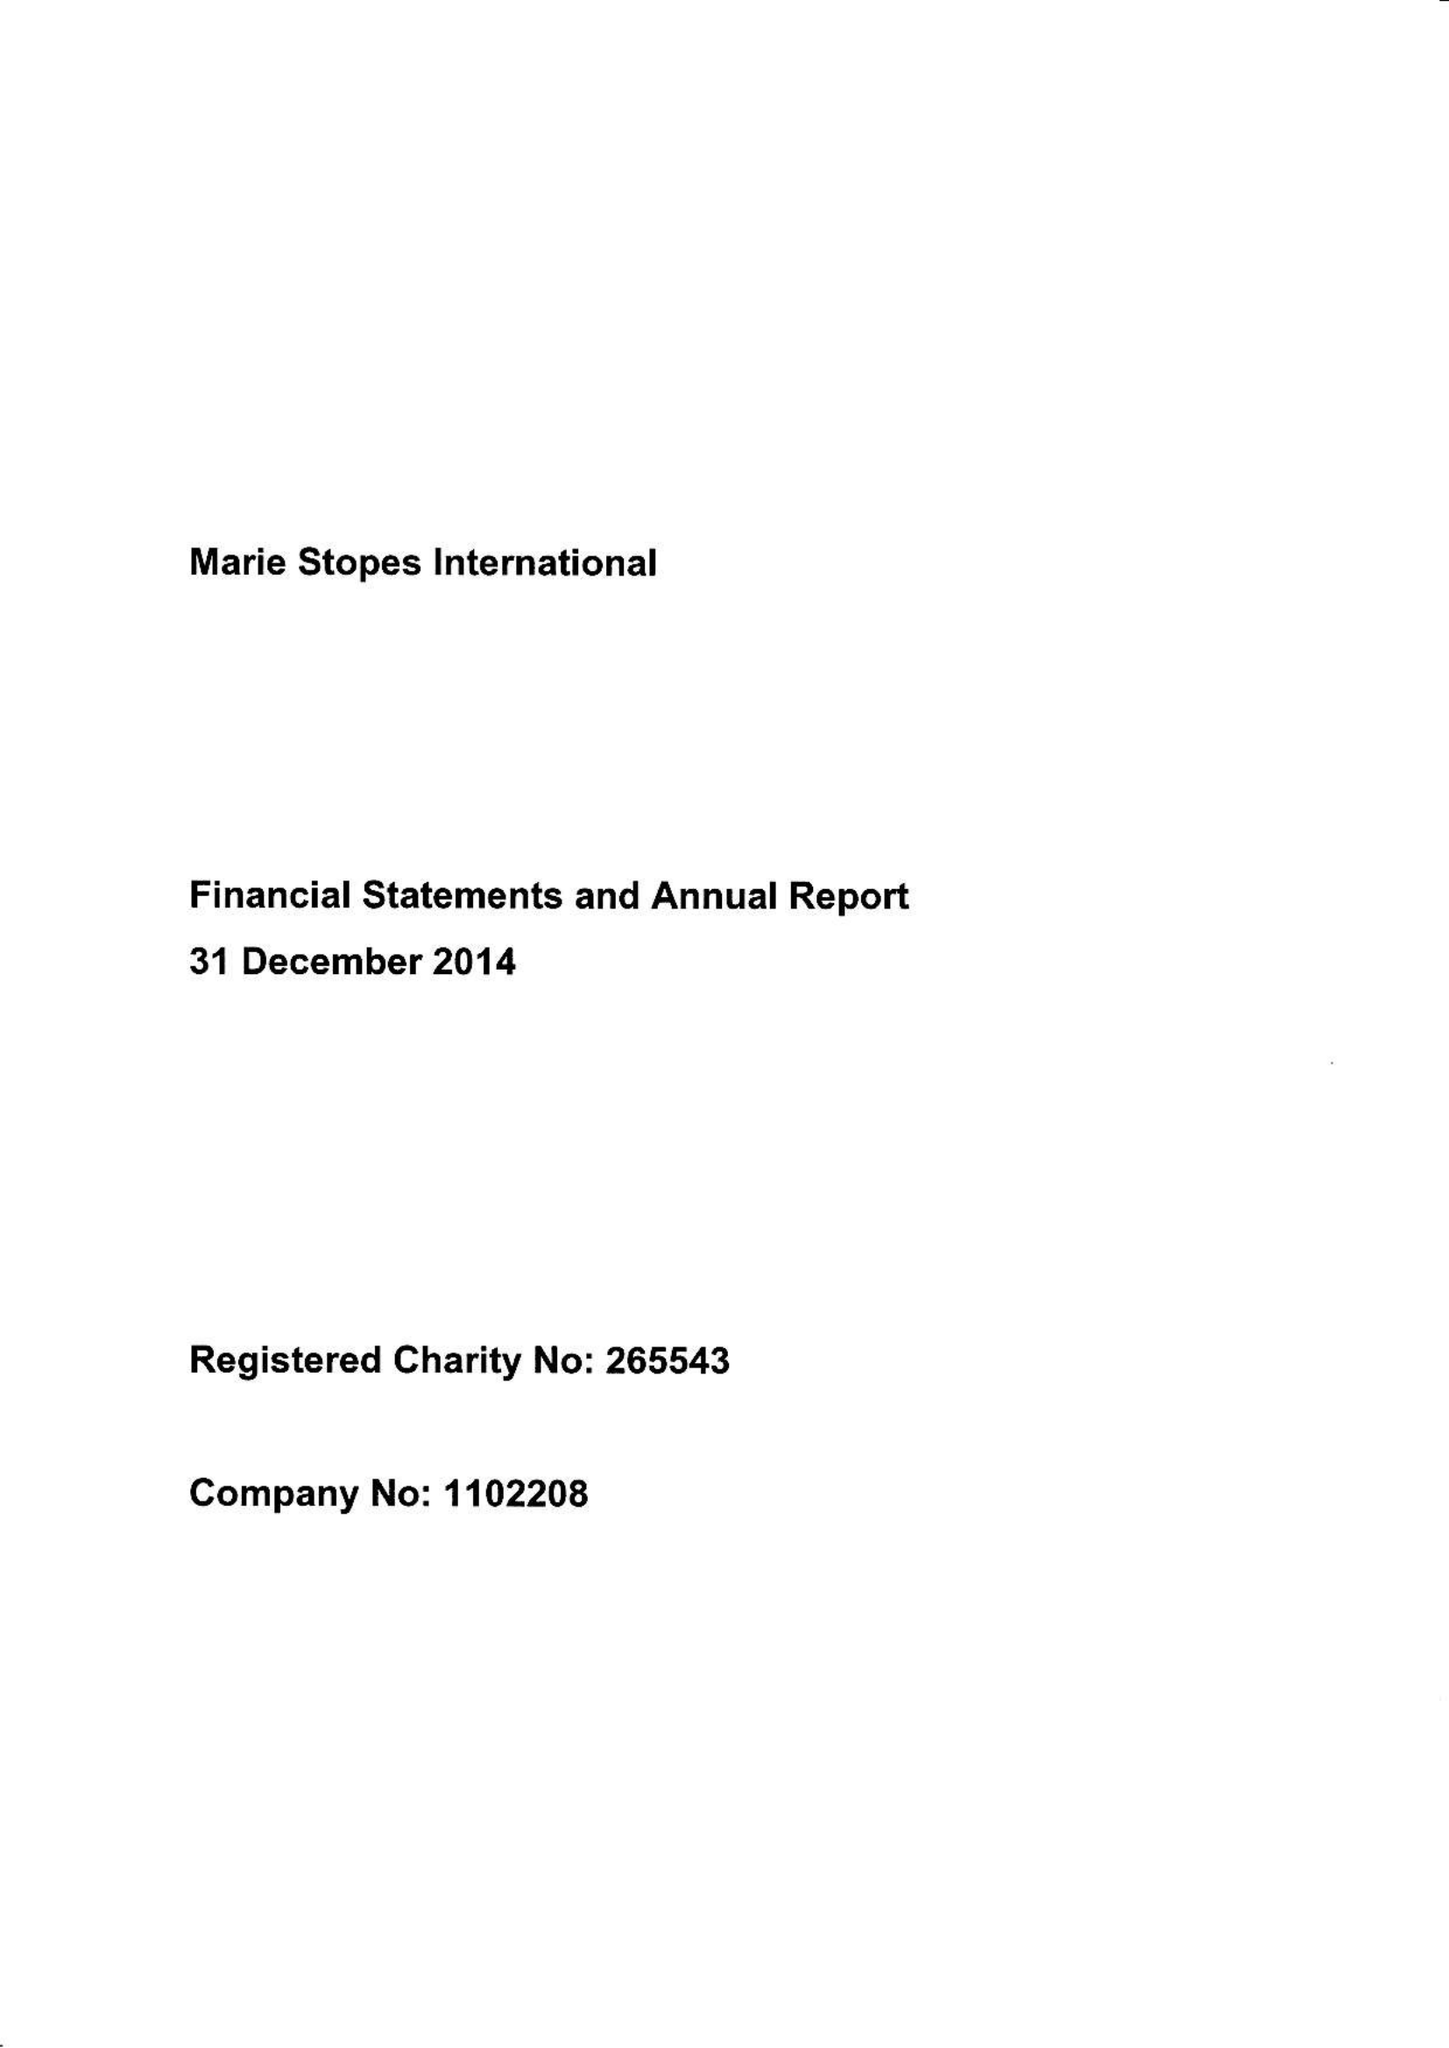What is the value for the report_date?
Answer the question using a single word or phrase. 2014-12-31 